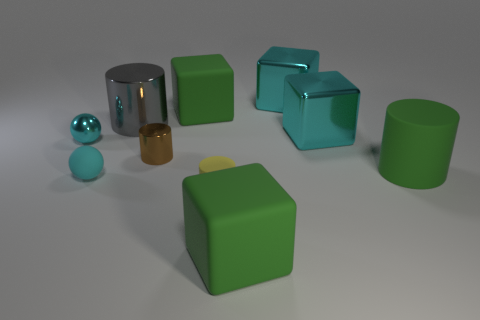Subtract all yellow cylinders. How many cylinders are left? 3 Subtract all purple cubes. Subtract all purple cylinders. How many cubes are left? 4 Subtract all cylinders. How many objects are left? 6 Add 7 small matte cubes. How many small matte cubes exist? 7 Subtract 0 gray cubes. How many objects are left? 10 Subtract all green matte things. Subtract all cyan matte spheres. How many objects are left? 6 Add 8 green rubber cubes. How many green rubber cubes are left? 10 